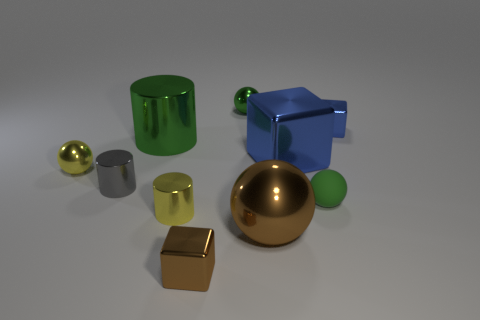There is a brown shiny ball that is in front of the gray cylinder; does it have the same size as the tiny yellow metallic sphere?
Give a very brief answer. No. Are there fewer large blue things than yellow metal things?
Offer a terse response. Yes. Is there a big ball made of the same material as the tiny brown thing?
Offer a terse response. Yes. What is the shape of the big thing that is in front of the large blue shiny thing?
Provide a succinct answer. Sphere. Do the cube left of the small green shiny ball and the large cylinder have the same color?
Offer a very short reply. No. Is the number of blue shiny objects that are in front of the tiny yellow cylinder less than the number of tiny gray rubber cylinders?
Make the answer very short. No. The large cylinder that is the same material as the big blue object is what color?
Offer a terse response. Green. There is a blue thing that is right of the big blue cube; how big is it?
Your answer should be compact. Small. Are the large cylinder and the big blue cube made of the same material?
Keep it short and to the point. Yes. There is a ball right of the large shiny cube that is in front of the tiny blue thing; is there a small green metal sphere that is in front of it?
Keep it short and to the point. No. 